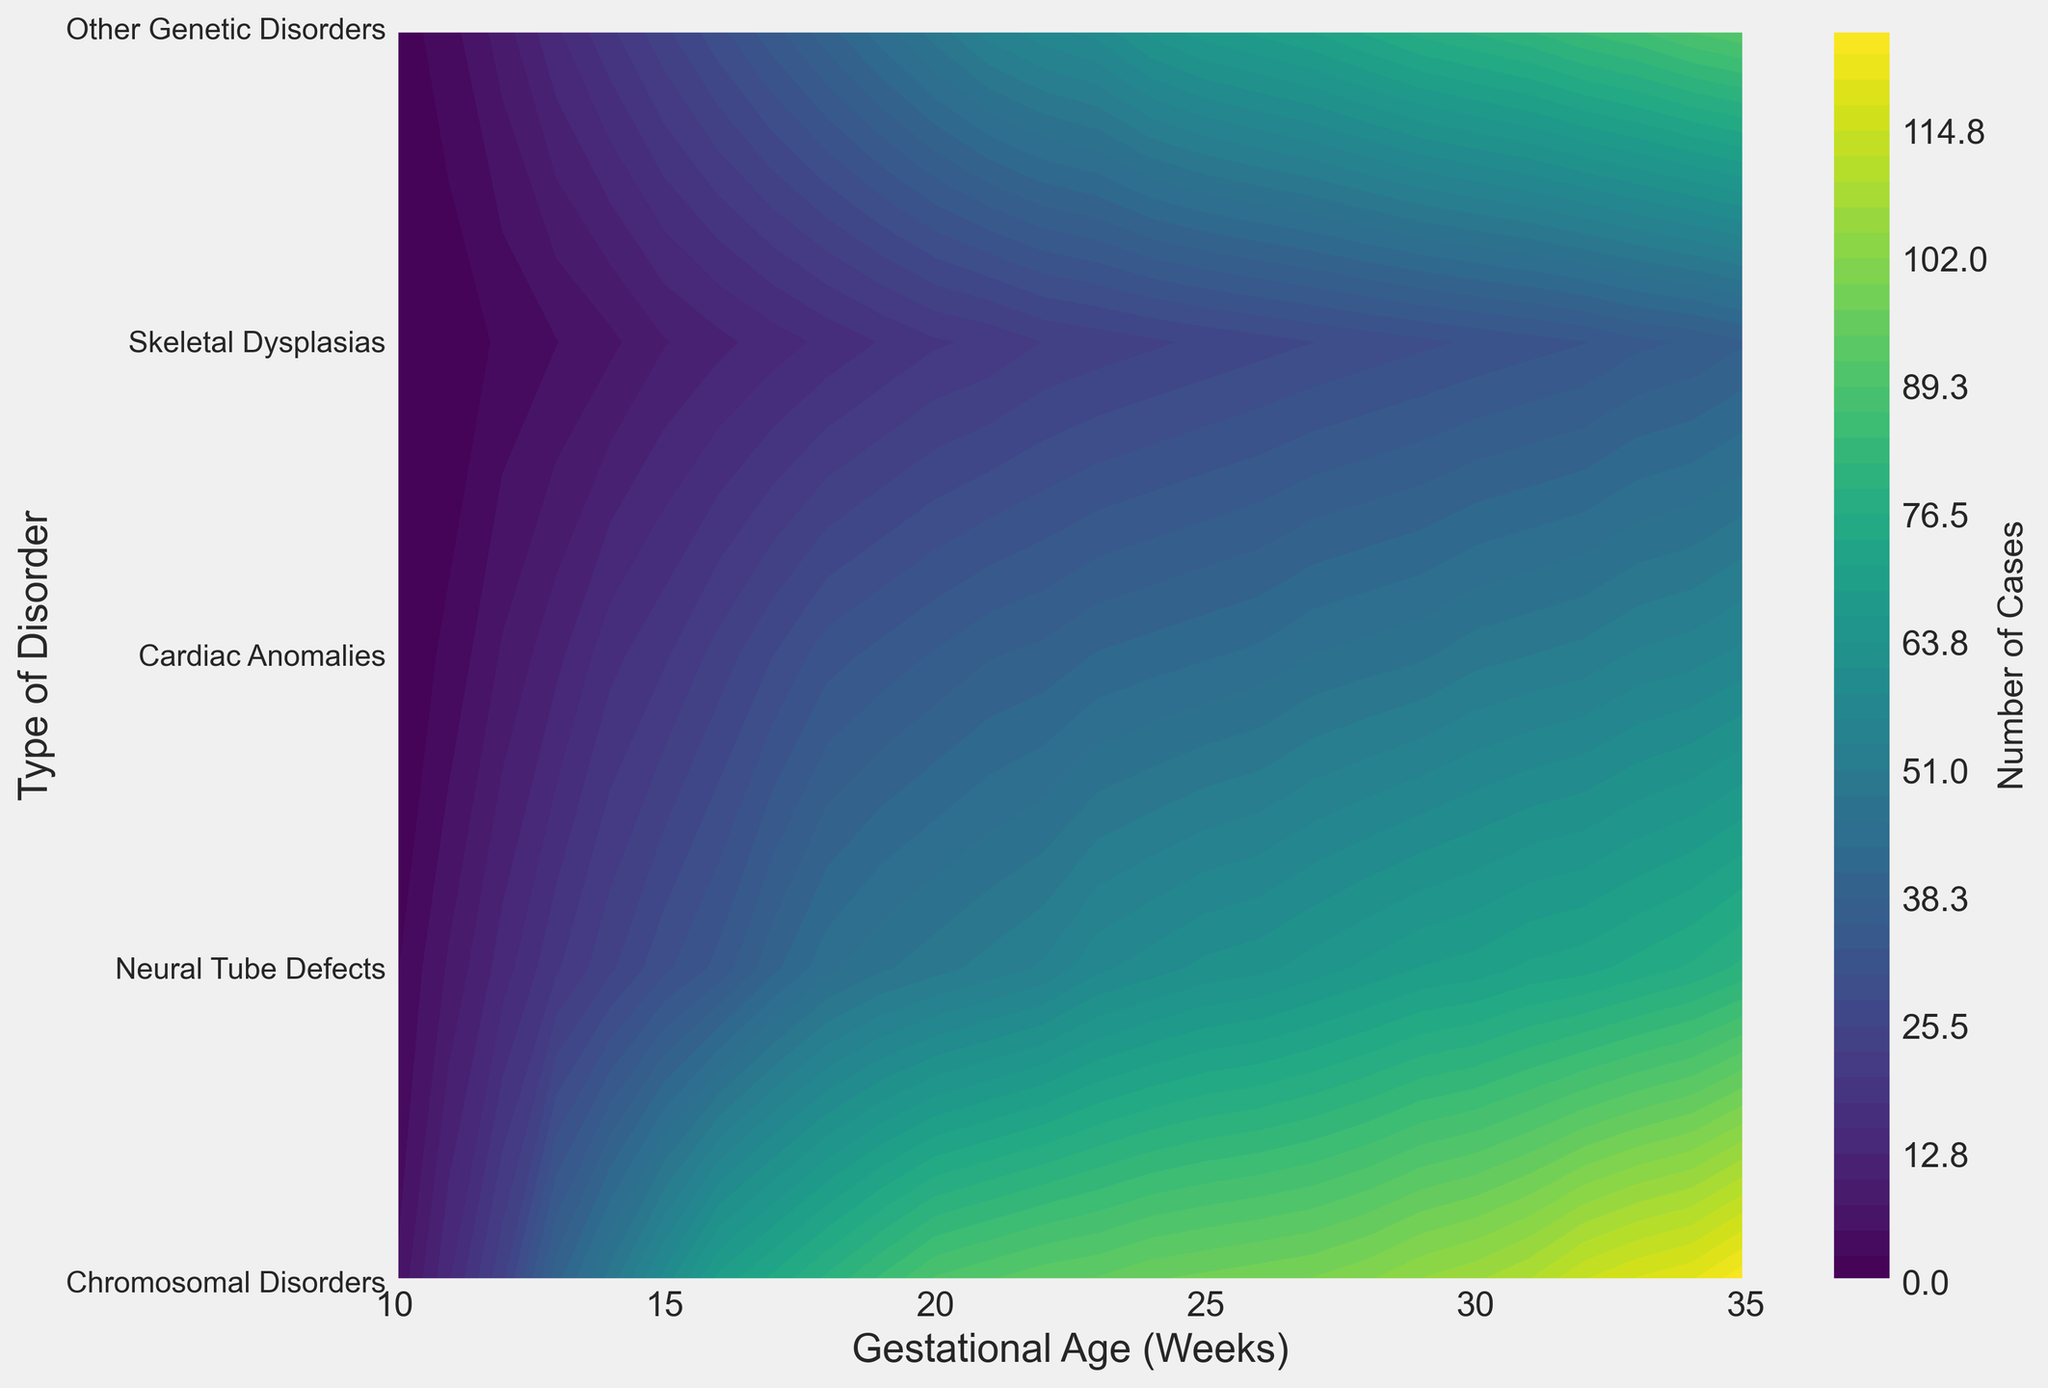What type of genetic disorder peaks the earliest in gestational age? The contour plot shows different levels of disorders by gestational age. The disorder with the highest visualized cases at the earliest gestational age (week 10) is Chromosomal Disorders, evident from the coloration/intensity.
Answer: Chromosomal Disorders Between weeks 15 and 20, which genetic disorder has the steepest increase in cases? To determine which genetic disorder has the steepest increase over the weeks 15 to 20, observe the contour lines' density and steepness. The contour lines of Chromosomal Disorders become denser and increase in value more rapidly than the others.
Answer: Chromosomal Disorders Which disorder shows the most consistent increase in cases across the gestational age range? By examining the contour plots across the full range of weeks, Chromosomal Disorders consistently show an increase without many plateaus, unlike other disorders that might flatten at certain points.
Answer: Chromosomal Disorders At gestational week 23, what is the approximate number of Neural Tube Defect cases? Locate gestational week 23 on the x-axis, trace upwards to the contour region corresponding to Neural Tube Defects, and reference the color bar for the approximate value, which is about 58 cases based on the color intensity.
Answer: 58 cases Which disorder shows a noticeable change in the number of detected cases starting from week 25? Examine week 25 and identify which disorder’s contour lines begin to steepen or change significantly. Cardiac Anomalies show a noticeable increase starting around this gestational age.
Answer: Cardiac Anomalies What is the difference in the number of Skeletal Dysplasias cases between weeks 17 and 22? Check the values for Skeletal Dysplasias at week 17 (14 cases) and week 22 (23 cases) by following the contour levels and performing a subtraction: 23 - 14.
Answer: 9 cases Compare the total number of cases for Chromosomal Disorders and Other Genetic Disorders at week 30. Which has more cases and by approximately how many? For week 30, follow the contour lines to find values for Chromosomal Disorders (107 cases) and Other Genetic Disorders (80 cases). Chromosomal Disorders have approximately 27 more cases (107 - 80).
Answer: Chromosomal Disorders, 27 more cases Which disorder, between Neural Tube Defects and Cardiac Anomalies, shows more variability in detected cases over the period of 20 to 30 weeks? Observe the contour density changes for the two disorders between weeks 20 and 30. Neural Tube Defects vary from 50 to 70 cases, while Cardiac Anomalies range from 36 to 50 cases, indicating greater variability in Neural Tube Defects.
Answer: Neural Tube Defects What is the approximate range of detected cases for Skeletal Dysplasias from week 20 to week 25? For Skeletal Dysplasias between weeks 20 and 25, observe values at these points: ~20 cases at week 20 and 26 cases at week 25, showing a range between these values.
Answer: 20-26 cases How does the increase in Chromosomal Disorders compare to the increase in Neural Tube Defects from week 10 to week 35? To compare the increases, note Chromosomal Disorders starts at 5 cases at week 10 and increases to ~125 cases by week 35. Neural Tube Defects start at 2 cases at week 10 and increase to ~80 cases. Chromosomal Disorders show a larger absolute increase (120 cases) compared to Neural Tube Defects (78 cases).
Answer: Chromosomal Disorders show a larger increase 